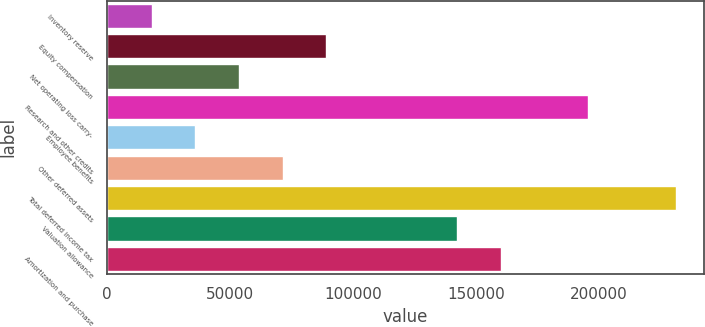<chart> <loc_0><loc_0><loc_500><loc_500><bar_chart><fcel>Inventory reserve<fcel>Equity compensation<fcel>Net operating loss carry-<fcel>Research and other credits<fcel>Employee benefits<fcel>Other deferred assets<fcel>Total deferred income tax<fcel>Valuation allowance<fcel>Amortization and purchase<nl><fcel>18087.6<fcel>89106<fcel>53596.8<fcel>195634<fcel>35842.2<fcel>71351.4<fcel>231143<fcel>142370<fcel>160124<nl></chart> 